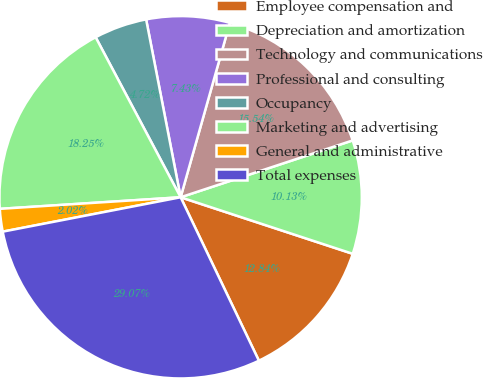Convert chart. <chart><loc_0><loc_0><loc_500><loc_500><pie_chart><fcel>Employee compensation and<fcel>Depreciation and amortization<fcel>Technology and communications<fcel>Professional and consulting<fcel>Occupancy<fcel>Marketing and advertising<fcel>General and administrative<fcel>Total expenses<nl><fcel>12.84%<fcel>10.13%<fcel>15.54%<fcel>7.43%<fcel>4.72%<fcel>18.25%<fcel>2.02%<fcel>29.07%<nl></chart> 